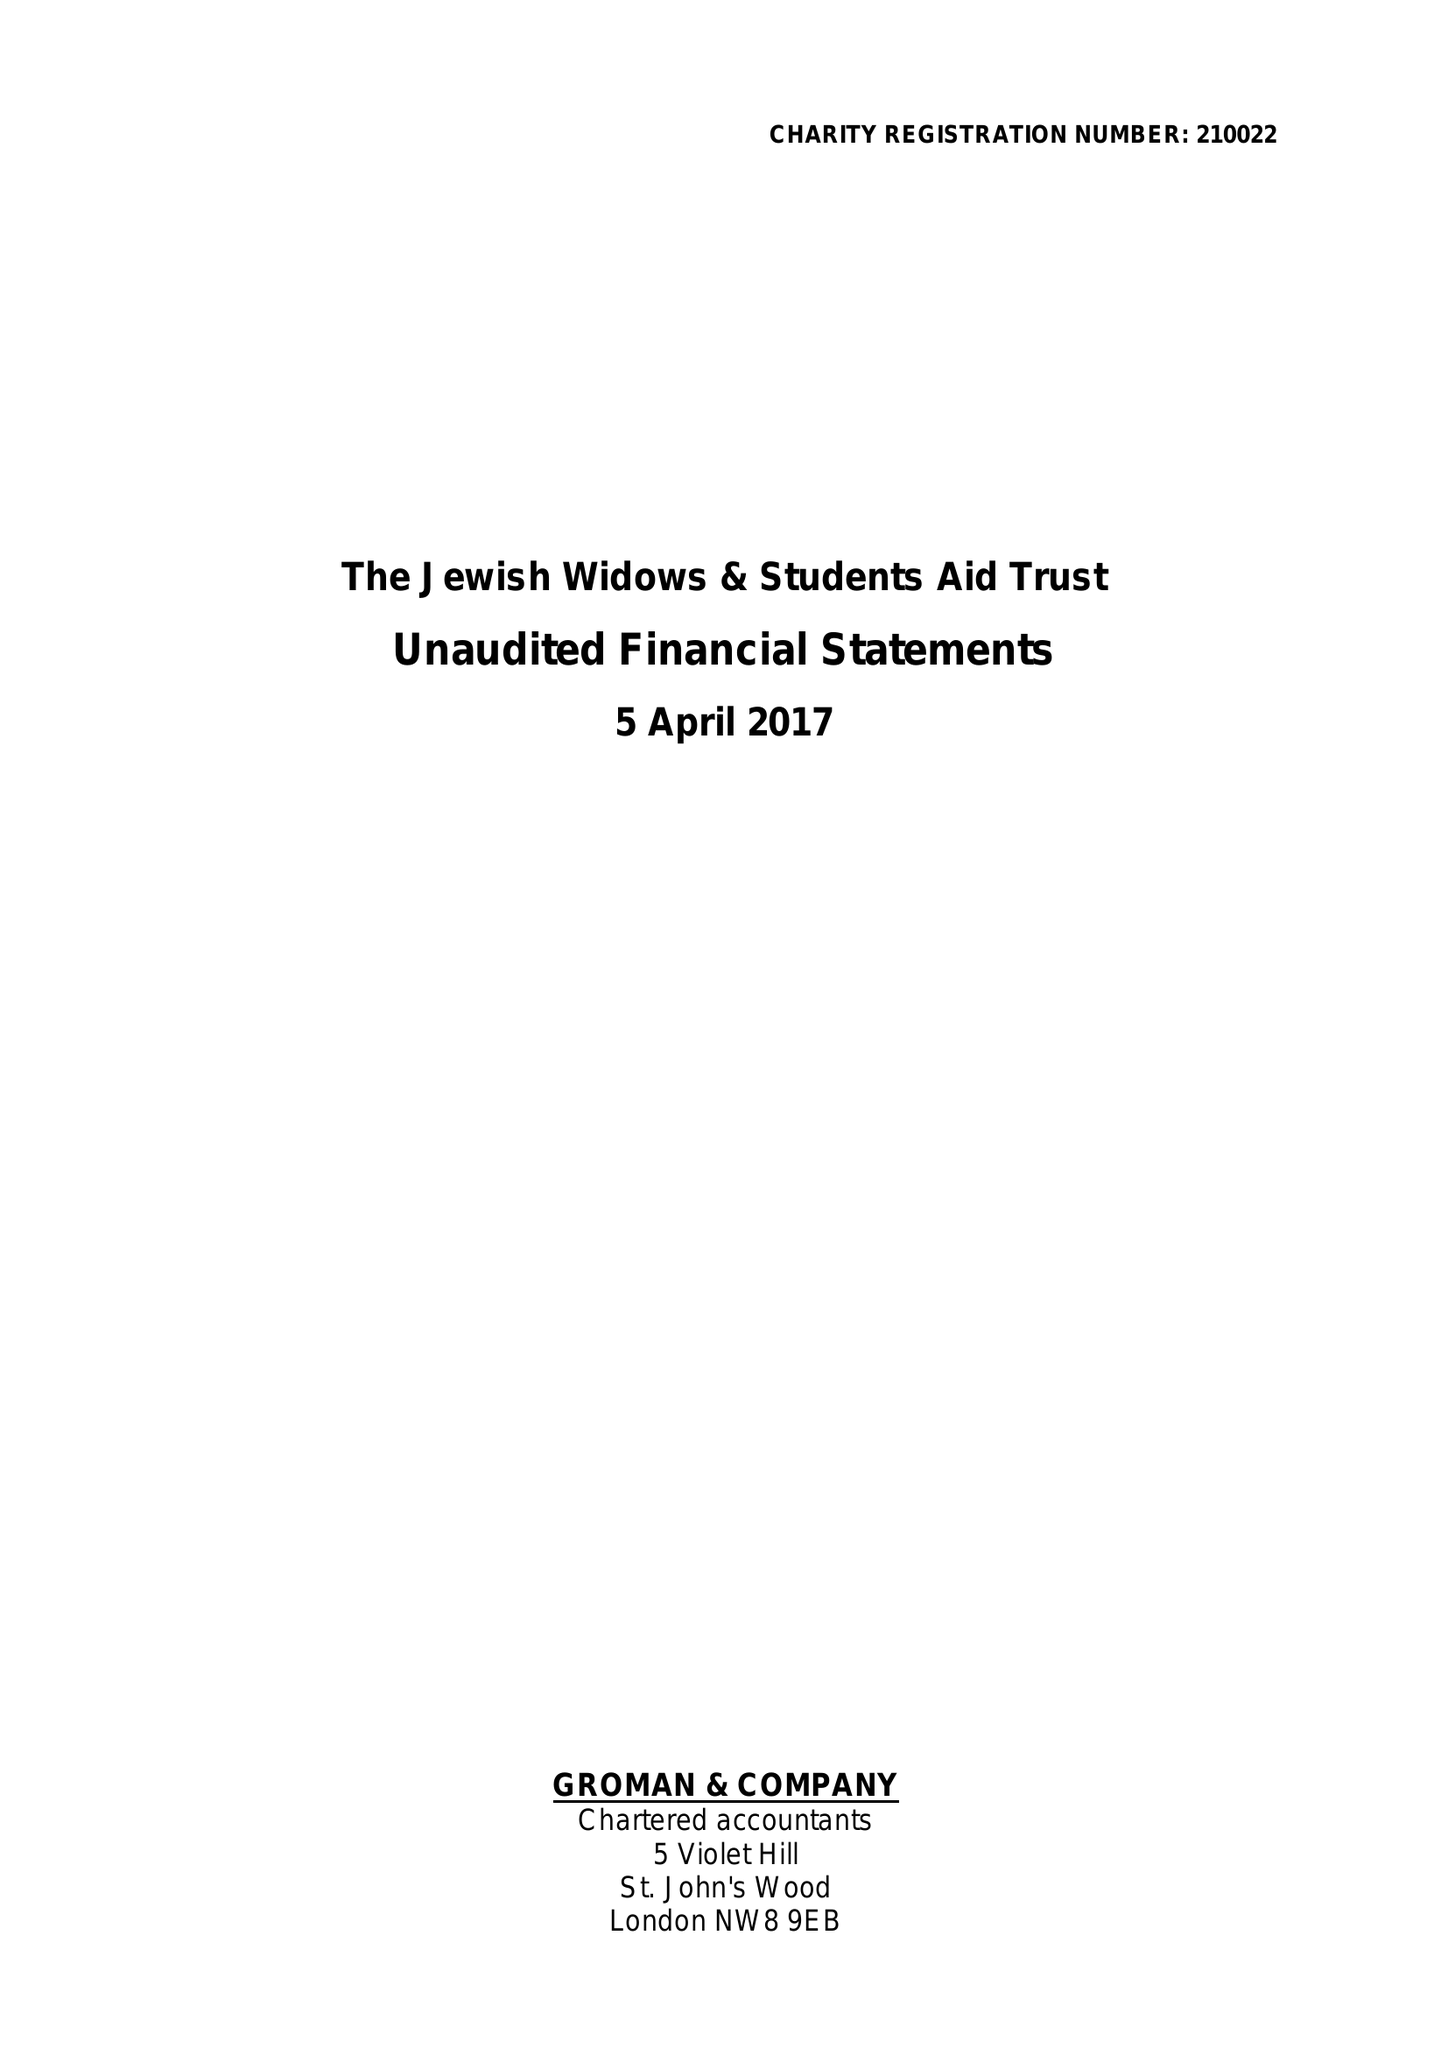What is the value for the income_annually_in_british_pounds?
Answer the question using a single word or phrase. 56088.00 